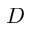Convert formula to latex. <formula><loc_0><loc_0><loc_500><loc_500>D</formula> 